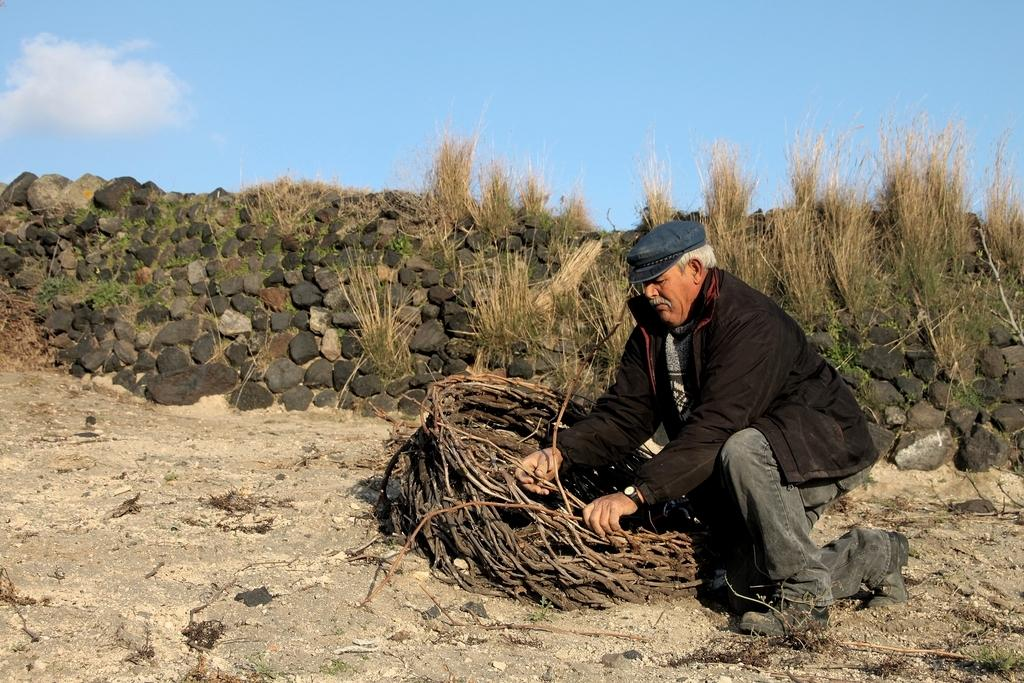Who is in the image? There is a man in the image. What is the man wearing? The man is wearing a black jacket. What position is the man in? The man is in a squat position. What type of terrain is visible in the image? There are stones and grass visible in the image. What part of the natural environment is visible in the image? The sky is visible in the image. Where is the scarecrow located in the image? There is no scarecrow present in the image. What type of weapon is the cannon in the image? There is no cannon present in the image. 